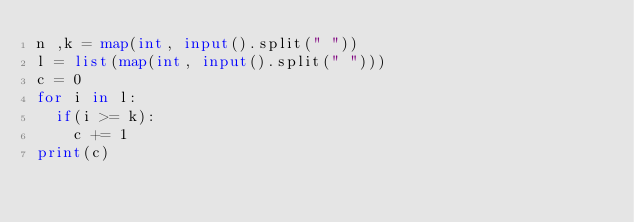Convert code to text. <code><loc_0><loc_0><loc_500><loc_500><_Python_>n ,k = map(int, input().split(" "))
l = list(map(int, input().split(" ")))
c = 0
for i in l:
	if(i >= k):
		c += 1
print(c)</code> 